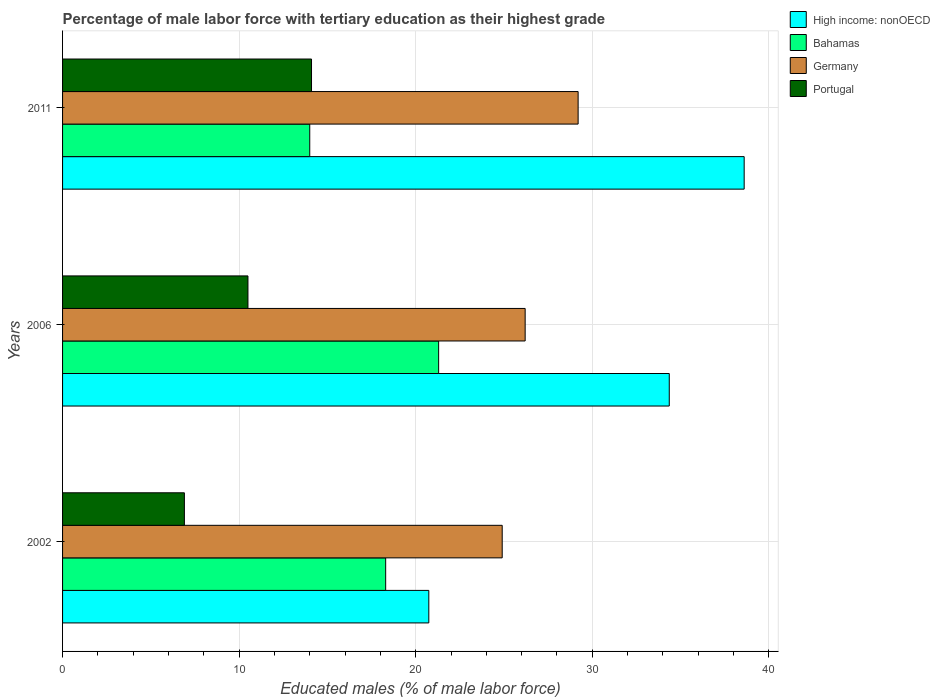How many different coloured bars are there?
Make the answer very short. 4. How many bars are there on the 2nd tick from the top?
Make the answer very short. 4. How many bars are there on the 2nd tick from the bottom?
Keep it short and to the point. 4. What is the label of the 2nd group of bars from the top?
Your response must be concise. 2006. In how many cases, is the number of bars for a given year not equal to the number of legend labels?
Make the answer very short. 0. What is the percentage of male labor force with tertiary education in High income: nonOECD in 2011?
Provide a short and direct response. 38.6. Across all years, what is the maximum percentage of male labor force with tertiary education in Bahamas?
Offer a terse response. 21.3. Across all years, what is the minimum percentage of male labor force with tertiary education in High income: nonOECD?
Provide a succinct answer. 20.74. In which year was the percentage of male labor force with tertiary education in Bahamas maximum?
Your response must be concise. 2006. In which year was the percentage of male labor force with tertiary education in Bahamas minimum?
Provide a short and direct response. 2011. What is the total percentage of male labor force with tertiary education in High income: nonOECD in the graph?
Offer a terse response. 93.71. What is the difference between the percentage of male labor force with tertiary education in Bahamas in 2002 and that in 2006?
Keep it short and to the point. -3. What is the difference between the percentage of male labor force with tertiary education in Portugal in 2011 and the percentage of male labor force with tertiary education in High income: nonOECD in 2002?
Provide a short and direct response. -6.64. What is the average percentage of male labor force with tertiary education in Bahamas per year?
Ensure brevity in your answer.  17.87. In the year 2011, what is the difference between the percentage of male labor force with tertiary education in High income: nonOECD and percentage of male labor force with tertiary education in Portugal?
Provide a succinct answer. 24.5. In how many years, is the percentage of male labor force with tertiary education in High income: nonOECD greater than 38 %?
Make the answer very short. 1. What is the ratio of the percentage of male labor force with tertiary education in Bahamas in 2006 to that in 2011?
Your answer should be compact. 1.52. Is the difference between the percentage of male labor force with tertiary education in High income: nonOECD in 2002 and 2006 greater than the difference between the percentage of male labor force with tertiary education in Portugal in 2002 and 2006?
Give a very brief answer. No. What is the difference between the highest and the second highest percentage of male labor force with tertiary education in High income: nonOECD?
Provide a short and direct response. 4.24. What is the difference between the highest and the lowest percentage of male labor force with tertiary education in Germany?
Your response must be concise. 4.3. Is the sum of the percentage of male labor force with tertiary education in Bahamas in 2006 and 2011 greater than the maximum percentage of male labor force with tertiary education in Portugal across all years?
Your answer should be compact. Yes. What does the 1st bar from the bottom in 2006 represents?
Offer a very short reply. High income: nonOECD. Are all the bars in the graph horizontal?
Your answer should be compact. Yes. How many years are there in the graph?
Give a very brief answer. 3. Where does the legend appear in the graph?
Your response must be concise. Top right. What is the title of the graph?
Offer a very short reply. Percentage of male labor force with tertiary education as their highest grade. What is the label or title of the X-axis?
Offer a terse response. Educated males (% of male labor force). What is the label or title of the Y-axis?
Make the answer very short. Years. What is the Educated males (% of male labor force) of High income: nonOECD in 2002?
Provide a succinct answer. 20.74. What is the Educated males (% of male labor force) in Bahamas in 2002?
Offer a terse response. 18.3. What is the Educated males (% of male labor force) in Germany in 2002?
Ensure brevity in your answer.  24.9. What is the Educated males (% of male labor force) of Portugal in 2002?
Offer a terse response. 6.9. What is the Educated males (% of male labor force) in High income: nonOECD in 2006?
Offer a very short reply. 34.36. What is the Educated males (% of male labor force) of Bahamas in 2006?
Ensure brevity in your answer.  21.3. What is the Educated males (% of male labor force) in Germany in 2006?
Offer a very short reply. 26.2. What is the Educated males (% of male labor force) of High income: nonOECD in 2011?
Your answer should be compact. 38.6. What is the Educated males (% of male labor force) of Germany in 2011?
Provide a succinct answer. 29.2. What is the Educated males (% of male labor force) of Portugal in 2011?
Keep it short and to the point. 14.1. Across all years, what is the maximum Educated males (% of male labor force) of High income: nonOECD?
Provide a succinct answer. 38.6. Across all years, what is the maximum Educated males (% of male labor force) of Bahamas?
Offer a very short reply. 21.3. Across all years, what is the maximum Educated males (% of male labor force) of Germany?
Make the answer very short. 29.2. Across all years, what is the maximum Educated males (% of male labor force) in Portugal?
Your answer should be very brief. 14.1. Across all years, what is the minimum Educated males (% of male labor force) in High income: nonOECD?
Keep it short and to the point. 20.74. Across all years, what is the minimum Educated males (% of male labor force) in Germany?
Your answer should be very brief. 24.9. Across all years, what is the minimum Educated males (% of male labor force) of Portugal?
Ensure brevity in your answer.  6.9. What is the total Educated males (% of male labor force) of High income: nonOECD in the graph?
Keep it short and to the point. 93.71. What is the total Educated males (% of male labor force) in Bahamas in the graph?
Offer a very short reply. 53.6. What is the total Educated males (% of male labor force) of Germany in the graph?
Provide a succinct answer. 80.3. What is the total Educated males (% of male labor force) in Portugal in the graph?
Offer a very short reply. 31.5. What is the difference between the Educated males (% of male labor force) of High income: nonOECD in 2002 and that in 2006?
Keep it short and to the point. -13.62. What is the difference between the Educated males (% of male labor force) in Bahamas in 2002 and that in 2006?
Your answer should be very brief. -3. What is the difference between the Educated males (% of male labor force) in Germany in 2002 and that in 2006?
Keep it short and to the point. -1.3. What is the difference between the Educated males (% of male labor force) in Portugal in 2002 and that in 2006?
Make the answer very short. -3.6. What is the difference between the Educated males (% of male labor force) of High income: nonOECD in 2002 and that in 2011?
Your answer should be very brief. -17.86. What is the difference between the Educated males (% of male labor force) of High income: nonOECD in 2006 and that in 2011?
Offer a very short reply. -4.24. What is the difference between the Educated males (% of male labor force) in Bahamas in 2006 and that in 2011?
Provide a succinct answer. 7.3. What is the difference between the Educated males (% of male labor force) in Portugal in 2006 and that in 2011?
Your answer should be compact. -3.6. What is the difference between the Educated males (% of male labor force) in High income: nonOECD in 2002 and the Educated males (% of male labor force) in Bahamas in 2006?
Provide a short and direct response. -0.56. What is the difference between the Educated males (% of male labor force) in High income: nonOECD in 2002 and the Educated males (% of male labor force) in Germany in 2006?
Provide a short and direct response. -5.46. What is the difference between the Educated males (% of male labor force) of High income: nonOECD in 2002 and the Educated males (% of male labor force) of Portugal in 2006?
Your answer should be very brief. 10.24. What is the difference between the Educated males (% of male labor force) in Bahamas in 2002 and the Educated males (% of male labor force) in Portugal in 2006?
Your response must be concise. 7.8. What is the difference between the Educated males (% of male labor force) in Germany in 2002 and the Educated males (% of male labor force) in Portugal in 2006?
Give a very brief answer. 14.4. What is the difference between the Educated males (% of male labor force) in High income: nonOECD in 2002 and the Educated males (% of male labor force) in Bahamas in 2011?
Your response must be concise. 6.74. What is the difference between the Educated males (% of male labor force) in High income: nonOECD in 2002 and the Educated males (% of male labor force) in Germany in 2011?
Your response must be concise. -8.46. What is the difference between the Educated males (% of male labor force) in High income: nonOECD in 2002 and the Educated males (% of male labor force) in Portugal in 2011?
Offer a very short reply. 6.64. What is the difference between the Educated males (% of male labor force) of Bahamas in 2002 and the Educated males (% of male labor force) of Portugal in 2011?
Offer a terse response. 4.2. What is the difference between the Educated males (% of male labor force) of Germany in 2002 and the Educated males (% of male labor force) of Portugal in 2011?
Keep it short and to the point. 10.8. What is the difference between the Educated males (% of male labor force) in High income: nonOECD in 2006 and the Educated males (% of male labor force) in Bahamas in 2011?
Give a very brief answer. 20.36. What is the difference between the Educated males (% of male labor force) in High income: nonOECD in 2006 and the Educated males (% of male labor force) in Germany in 2011?
Keep it short and to the point. 5.16. What is the difference between the Educated males (% of male labor force) of High income: nonOECD in 2006 and the Educated males (% of male labor force) of Portugal in 2011?
Provide a succinct answer. 20.26. What is the difference between the Educated males (% of male labor force) of Bahamas in 2006 and the Educated males (% of male labor force) of Germany in 2011?
Your response must be concise. -7.9. What is the difference between the Educated males (% of male labor force) in Bahamas in 2006 and the Educated males (% of male labor force) in Portugal in 2011?
Give a very brief answer. 7.2. What is the difference between the Educated males (% of male labor force) of Germany in 2006 and the Educated males (% of male labor force) of Portugal in 2011?
Keep it short and to the point. 12.1. What is the average Educated males (% of male labor force) of High income: nonOECD per year?
Offer a very short reply. 31.24. What is the average Educated males (% of male labor force) of Bahamas per year?
Your answer should be compact. 17.87. What is the average Educated males (% of male labor force) in Germany per year?
Your response must be concise. 26.77. In the year 2002, what is the difference between the Educated males (% of male labor force) of High income: nonOECD and Educated males (% of male labor force) of Bahamas?
Your answer should be compact. 2.44. In the year 2002, what is the difference between the Educated males (% of male labor force) in High income: nonOECD and Educated males (% of male labor force) in Germany?
Your response must be concise. -4.16. In the year 2002, what is the difference between the Educated males (% of male labor force) in High income: nonOECD and Educated males (% of male labor force) in Portugal?
Your answer should be compact. 13.84. In the year 2002, what is the difference between the Educated males (% of male labor force) of Bahamas and Educated males (% of male labor force) of Germany?
Ensure brevity in your answer.  -6.6. In the year 2002, what is the difference between the Educated males (% of male labor force) of Bahamas and Educated males (% of male labor force) of Portugal?
Your answer should be compact. 11.4. In the year 2006, what is the difference between the Educated males (% of male labor force) of High income: nonOECD and Educated males (% of male labor force) of Bahamas?
Offer a terse response. 13.06. In the year 2006, what is the difference between the Educated males (% of male labor force) in High income: nonOECD and Educated males (% of male labor force) in Germany?
Ensure brevity in your answer.  8.16. In the year 2006, what is the difference between the Educated males (% of male labor force) of High income: nonOECD and Educated males (% of male labor force) of Portugal?
Offer a terse response. 23.86. In the year 2006, what is the difference between the Educated males (% of male labor force) of Bahamas and Educated males (% of male labor force) of Portugal?
Provide a succinct answer. 10.8. In the year 2006, what is the difference between the Educated males (% of male labor force) in Germany and Educated males (% of male labor force) in Portugal?
Your answer should be compact. 15.7. In the year 2011, what is the difference between the Educated males (% of male labor force) in High income: nonOECD and Educated males (% of male labor force) in Bahamas?
Offer a terse response. 24.6. In the year 2011, what is the difference between the Educated males (% of male labor force) in High income: nonOECD and Educated males (% of male labor force) in Germany?
Keep it short and to the point. 9.4. In the year 2011, what is the difference between the Educated males (% of male labor force) in High income: nonOECD and Educated males (% of male labor force) in Portugal?
Keep it short and to the point. 24.5. In the year 2011, what is the difference between the Educated males (% of male labor force) in Bahamas and Educated males (% of male labor force) in Germany?
Your response must be concise. -15.2. What is the ratio of the Educated males (% of male labor force) in High income: nonOECD in 2002 to that in 2006?
Ensure brevity in your answer.  0.6. What is the ratio of the Educated males (% of male labor force) in Bahamas in 2002 to that in 2006?
Make the answer very short. 0.86. What is the ratio of the Educated males (% of male labor force) of Germany in 2002 to that in 2006?
Your answer should be compact. 0.95. What is the ratio of the Educated males (% of male labor force) of Portugal in 2002 to that in 2006?
Ensure brevity in your answer.  0.66. What is the ratio of the Educated males (% of male labor force) in High income: nonOECD in 2002 to that in 2011?
Your response must be concise. 0.54. What is the ratio of the Educated males (% of male labor force) in Bahamas in 2002 to that in 2011?
Your response must be concise. 1.31. What is the ratio of the Educated males (% of male labor force) in Germany in 2002 to that in 2011?
Offer a very short reply. 0.85. What is the ratio of the Educated males (% of male labor force) of Portugal in 2002 to that in 2011?
Your response must be concise. 0.49. What is the ratio of the Educated males (% of male labor force) in High income: nonOECD in 2006 to that in 2011?
Your answer should be compact. 0.89. What is the ratio of the Educated males (% of male labor force) of Bahamas in 2006 to that in 2011?
Provide a succinct answer. 1.52. What is the ratio of the Educated males (% of male labor force) of Germany in 2006 to that in 2011?
Offer a very short reply. 0.9. What is the ratio of the Educated males (% of male labor force) of Portugal in 2006 to that in 2011?
Offer a very short reply. 0.74. What is the difference between the highest and the second highest Educated males (% of male labor force) of High income: nonOECD?
Make the answer very short. 4.24. What is the difference between the highest and the second highest Educated males (% of male labor force) of Portugal?
Your response must be concise. 3.6. What is the difference between the highest and the lowest Educated males (% of male labor force) in High income: nonOECD?
Your answer should be very brief. 17.86. What is the difference between the highest and the lowest Educated males (% of male labor force) of Bahamas?
Make the answer very short. 7.3. What is the difference between the highest and the lowest Educated males (% of male labor force) in Germany?
Make the answer very short. 4.3. What is the difference between the highest and the lowest Educated males (% of male labor force) in Portugal?
Offer a terse response. 7.2. 